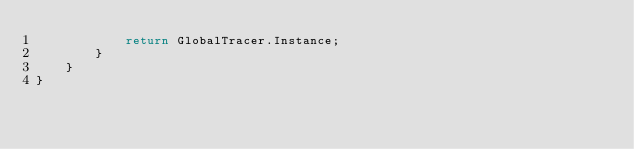Convert code to text. <code><loc_0><loc_0><loc_500><loc_500><_C#_>            return GlobalTracer.Instance;
        }
    }
}
</code> 